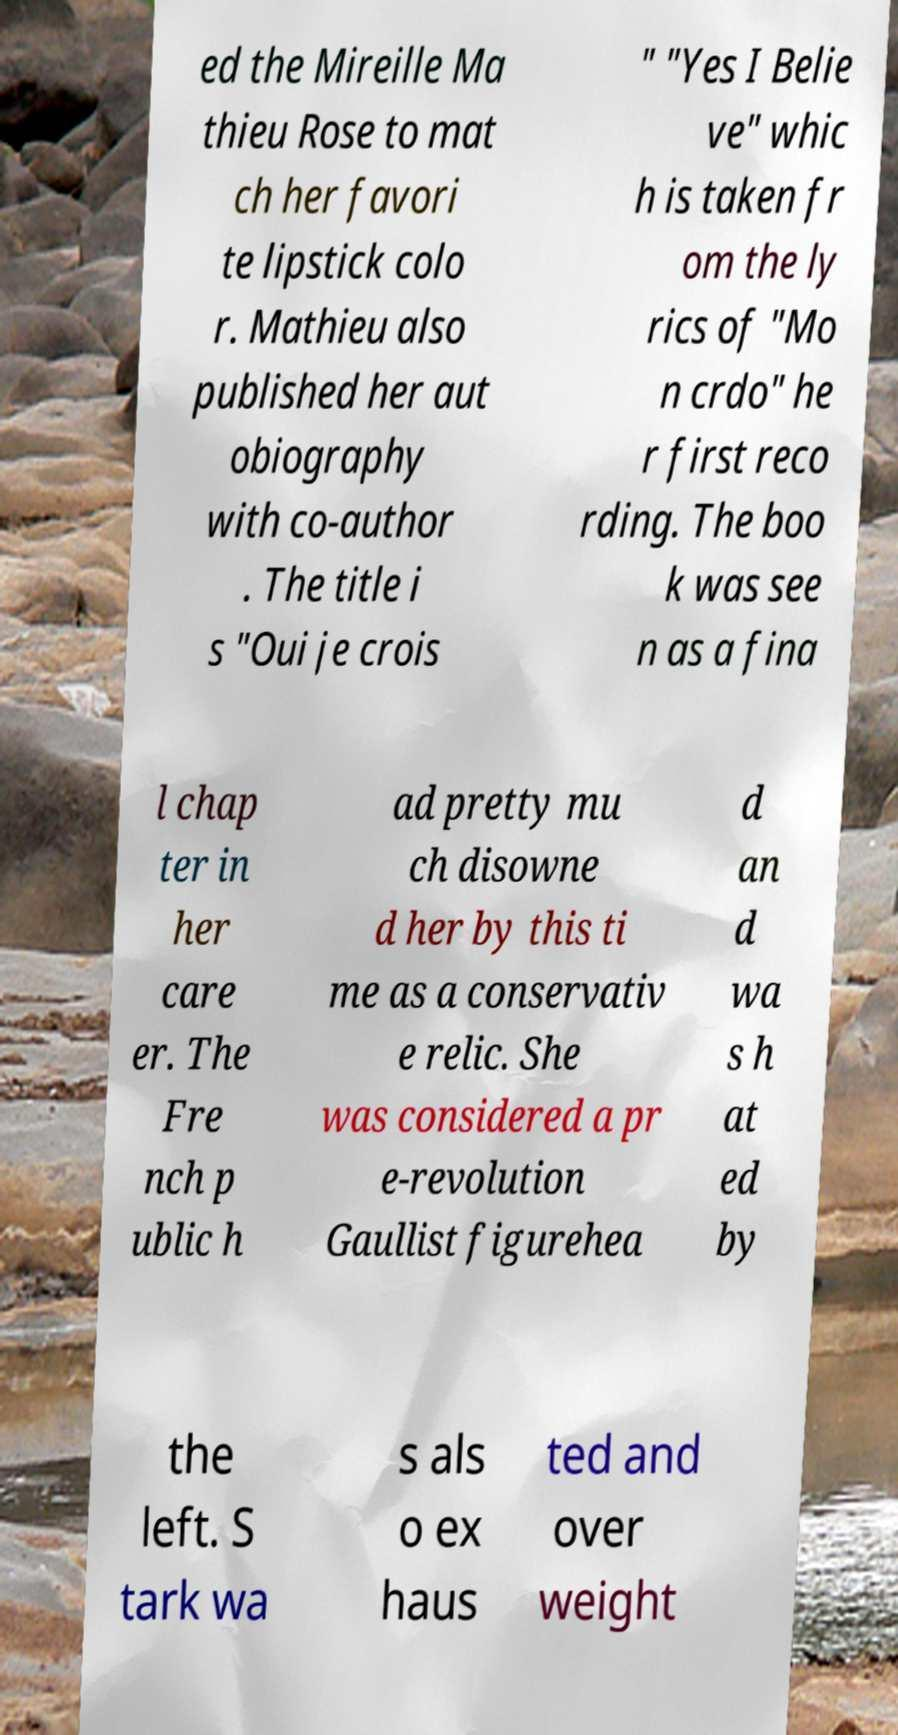Could you assist in decoding the text presented in this image and type it out clearly? ed the Mireille Ma thieu Rose to mat ch her favori te lipstick colo r. Mathieu also published her aut obiography with co-author . The title i s "Oui je crois " "Yes I Belie ve" whic h is taken fr om the ly rics of "Mo n crdo" he r first reco rding. The boo k was see n as a fina l chap ter in her care er. The Fre nch p ublic h ad pretty mu ch disowne d her by this ti me as a conservativ e relic. She was considered a pr e-revolution Gaullist figurehea d an d wa s h at ed by the left. S tark wa s als o ex haus ted and over weight 